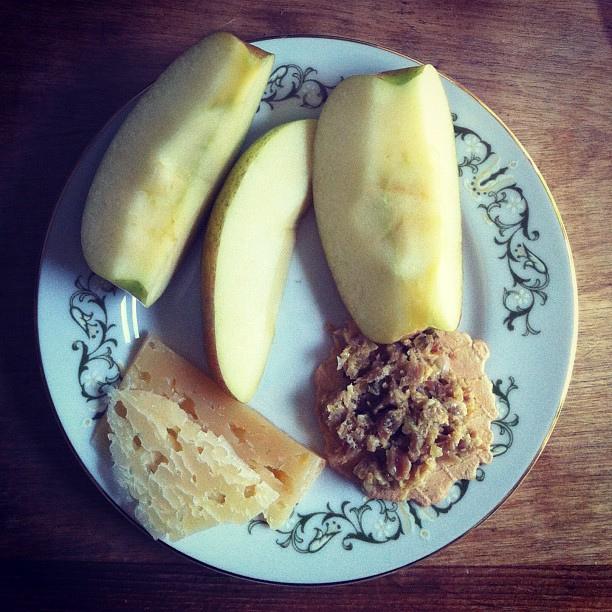What kind of fruit is on the plate?
Give a very brief answer. Apple. How many pieces of apple are on the plate?
Quick response, please. 3. What kind of cheese is on the plate?
Short answer required. Swiss. What type of pattern is on the plate?
Write a very short answer. Vines. Is this a vegetarian breakfast?
Write a very short answer. Yes. 